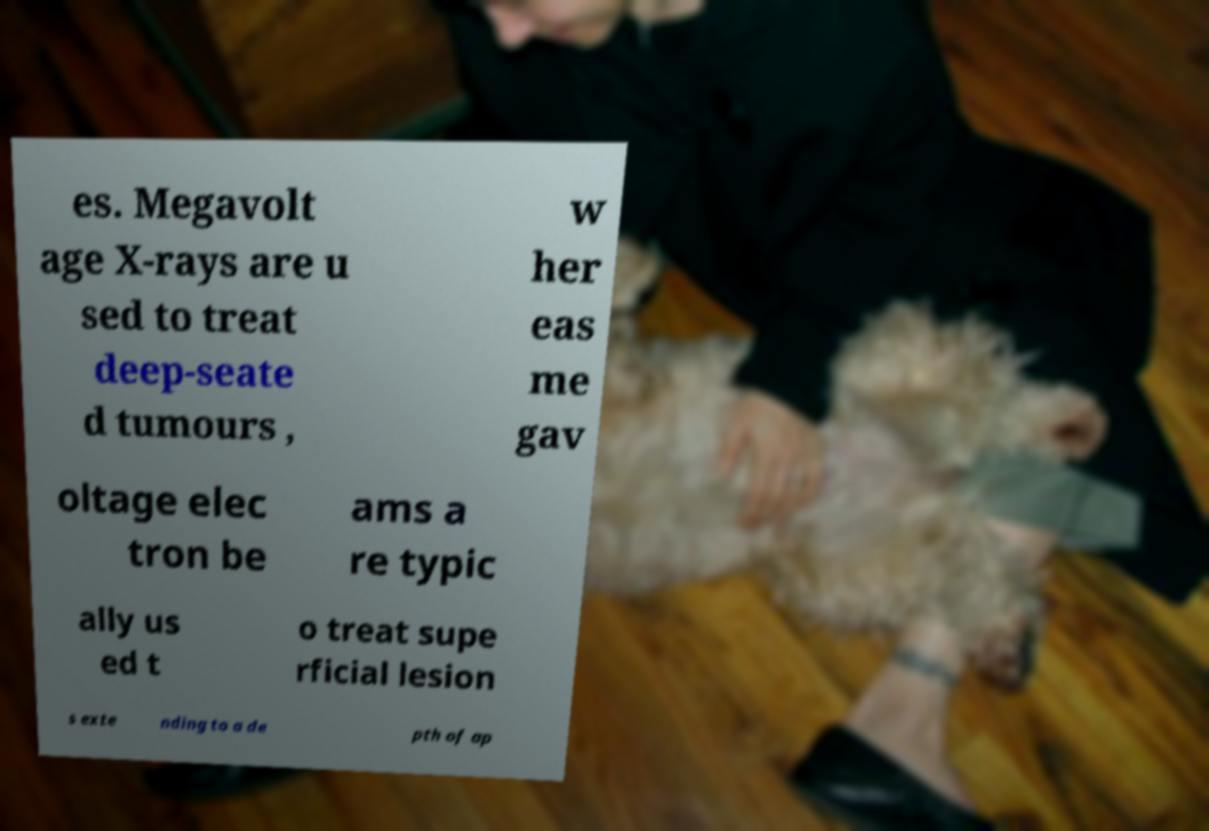Please identify and transcribe the text found in this image. es. Megavolt age X-rays are u sed to treat deep-seate d tumours , w her eas me gav oltage elec tron be ams a re typic ally us ed t o treat supe rficial lesion s exte nding to a de pth of ap 